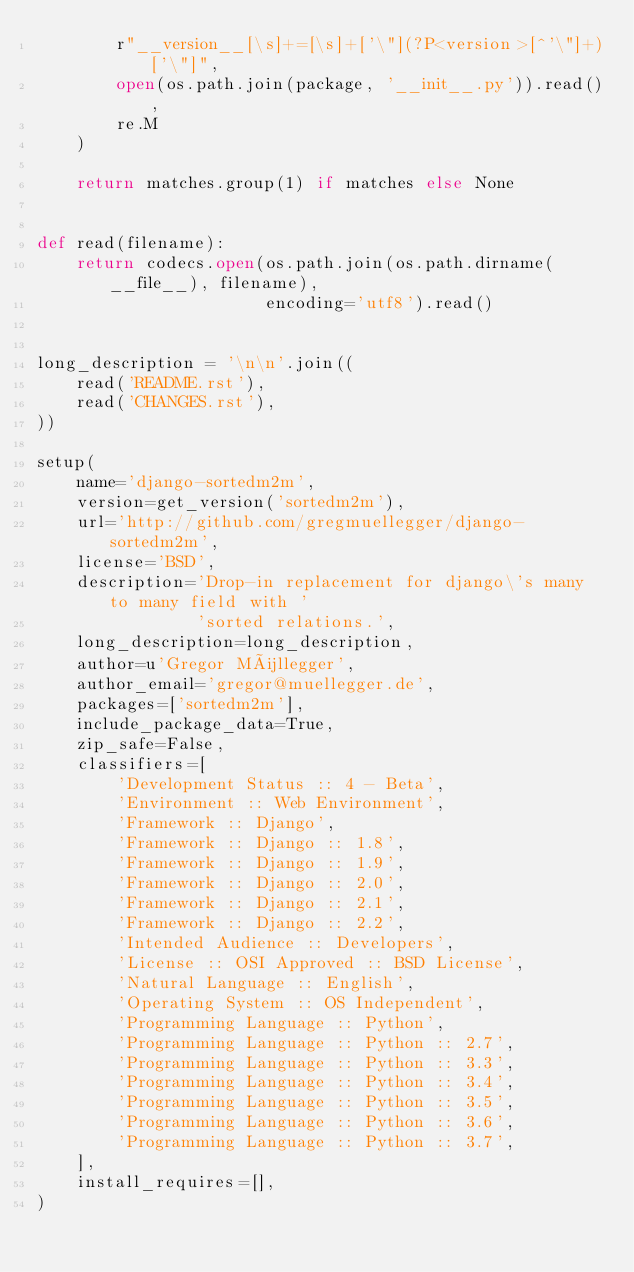Convert code to text. <code><loc_0><loc_0><loc_500><loc_500><_Python_>        r"__version__[\s]+=[\s]+['\"](?P<version>[^'\"]+)['\"]",
        open(os.path.join(package, '__init__.py')).read(),
        re.M
    )

    return matches.group(1) if matches else None


def read(filename):
    return codecs.open(os.path.join(os.path.dirname(__file__), filename),
                       encoding='utf8').read()


long_description = '\n\n'.join((
    read('README.rst'),
    read('CHANGES.rst'),
))

setup(
    name='django-sortedm2m',
    version=get_version('sortedm2m'),
    url='http://github.com/gregmuellegger/django-sortedm2m',
    license='BSD',
    description='Drop-in replacement for django\'s many to many field with '
                'sorted relations.',
    long_description=long_description,
    author=u'Gregor Müllegger',
    author_email='gregor@muellegger.de',
    packages=['sortedm2m'],
    include_package_data=True,
    zip_safe=False,
    classifiers=[
        'Development Status :: 4 - Beta',
        'Environment :: Web Environment',
        'Framework :: Django',
        'Framework :: Django :: 1.8',
        'Framework :: Django :: 1.9',
        'Framework :: Django :: 2.0',
        'Framework :: Django :: 2.1',
        'Framework :: Django :: 2.2',
        'Intended Audience :: Developers',
        'License :: OSI Approved :: BSD License',
        'Natural Language :: English',
        'Operating System :: OS Independent',
        'Programming Language :: Python',
        'Programming Language :: Python :: 2.7',
        'Programming Language :: Python :: 3.3',
        'Programming Language :: Python :: 3.4',
        'Programming Language :: Python :: 3.5',
        'Programming Language :: Python :: 3.6',
        'Programming Language :: Python :: 3.7',
    ],
    install_requires=[],
)
</code> 